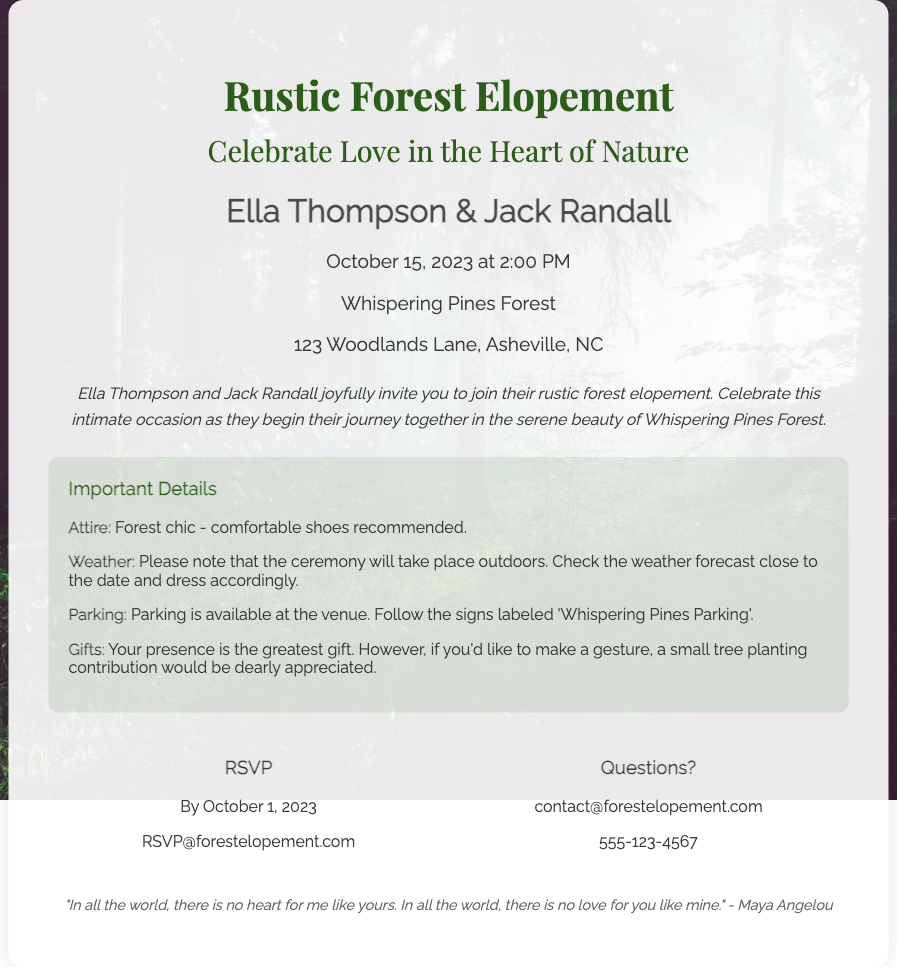What are the names of the couple? The invitation prominently mentions the names of the couple getting married as Ella Thompson and Jack Randall.
Answer: Ella Thompson & Jack Randall What is the date of the elopement? The document specifies the date for the elopement as October 15, 2023.
Answer: October 15, 2023 Where is the ceremony taking place? The location of the ceremony is stated in the document as Whispering Pines Forest.
Answer: Whispering Pines Forest What is the recommended attire for guests? The important details section indicates that the recommended attire is "Forest chic".
Answer: Forest chic What is the RSVP deadline? The invitation includes an RSVP date, which is stated as by October 1, 2023.
Answer: By October 1, 2023 What type of gift is suggested for the couple? According to the invitation, guests are encouraged to make a "small tree planting contribution" as a gesture.
Answer: A small tree planting contribution Why is Ella and Jack's ceremony unique? The invitation highlights that the ceremony is an "intimate occasion" celebrating their love in nature.
Answer: Intimate occasion What is provided for parking? The details section mentions that parking is available at the venue and includes specific signs for guiding guests.
Answer: Parking is available What time does the ceremony start? The document specifies the starting time of the ceremony as 2:00 PM.
Answer: 2:00 PM 